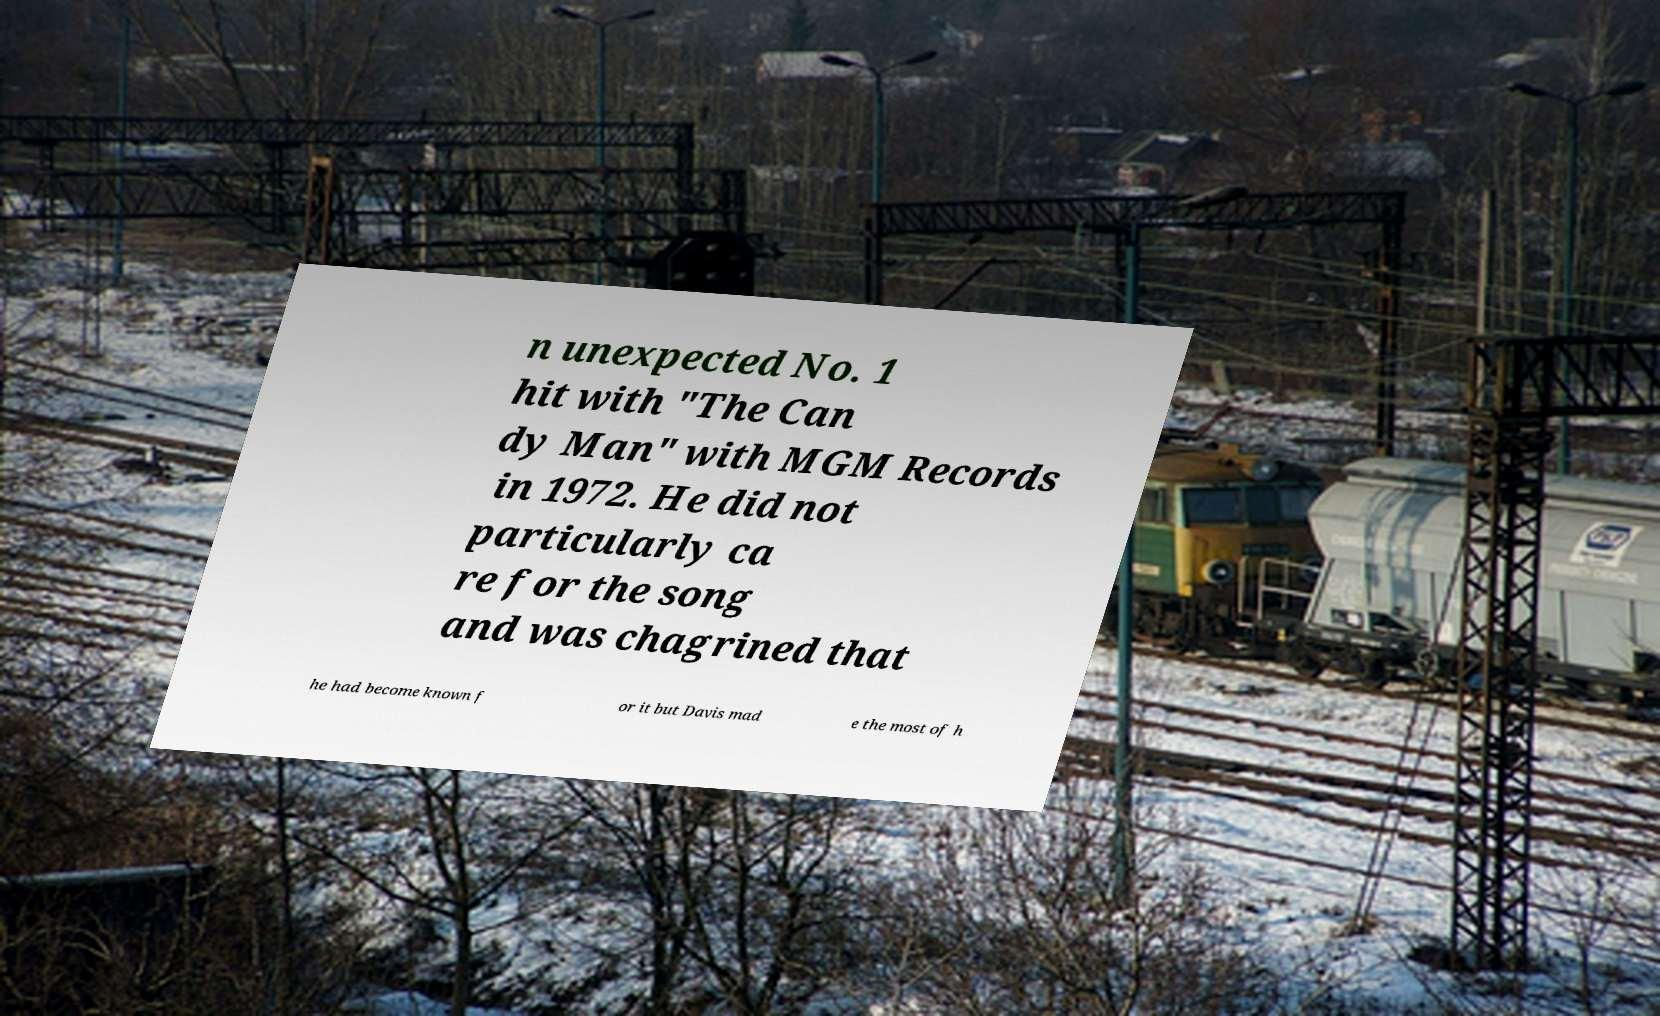For documentation purposes, I need the text within this image transcribed. Could you provide that? n unexpected No. 1 hit with "The Can dy Man" with MGM Records in 1972. He did not particularly ca re for the song and was chagrined that he had become known f or it but Davis mad e the most of h 